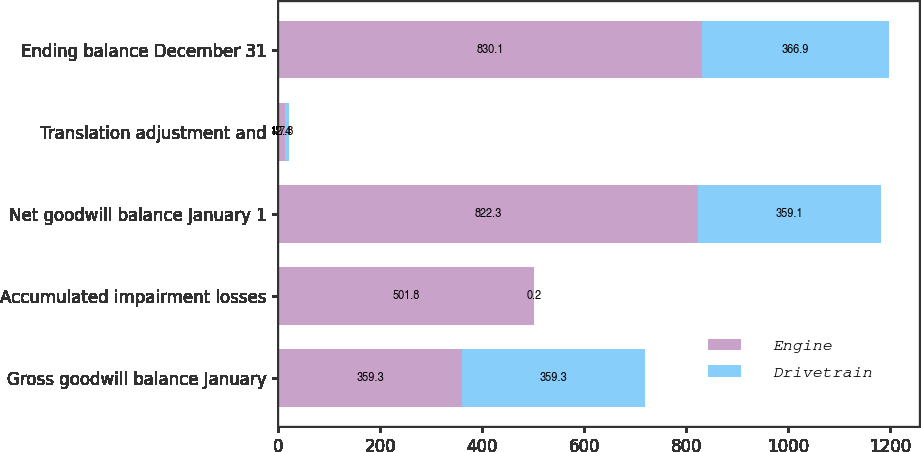<chart> <loc_0><loc_0><loc_500><loc_500><stacked_bar_chart><ecel><fcel>Gross goodwill balance January<fcel>Accumulated impairment losses<fcel>Net goodwill balance January 1<fcel>Translation adjustment and<fcel>Ending balance December 31<nl><fcel>Engine<fcel>359.3<fcel>501.8<fcel>822.3<fcel>12.4<fcel>830.1<nl><fcel>Drivetrain<fcel>359.3<fcel>0.2<fcel>359.1<fcel>7.8<fcel>366.9<nl></chart> 